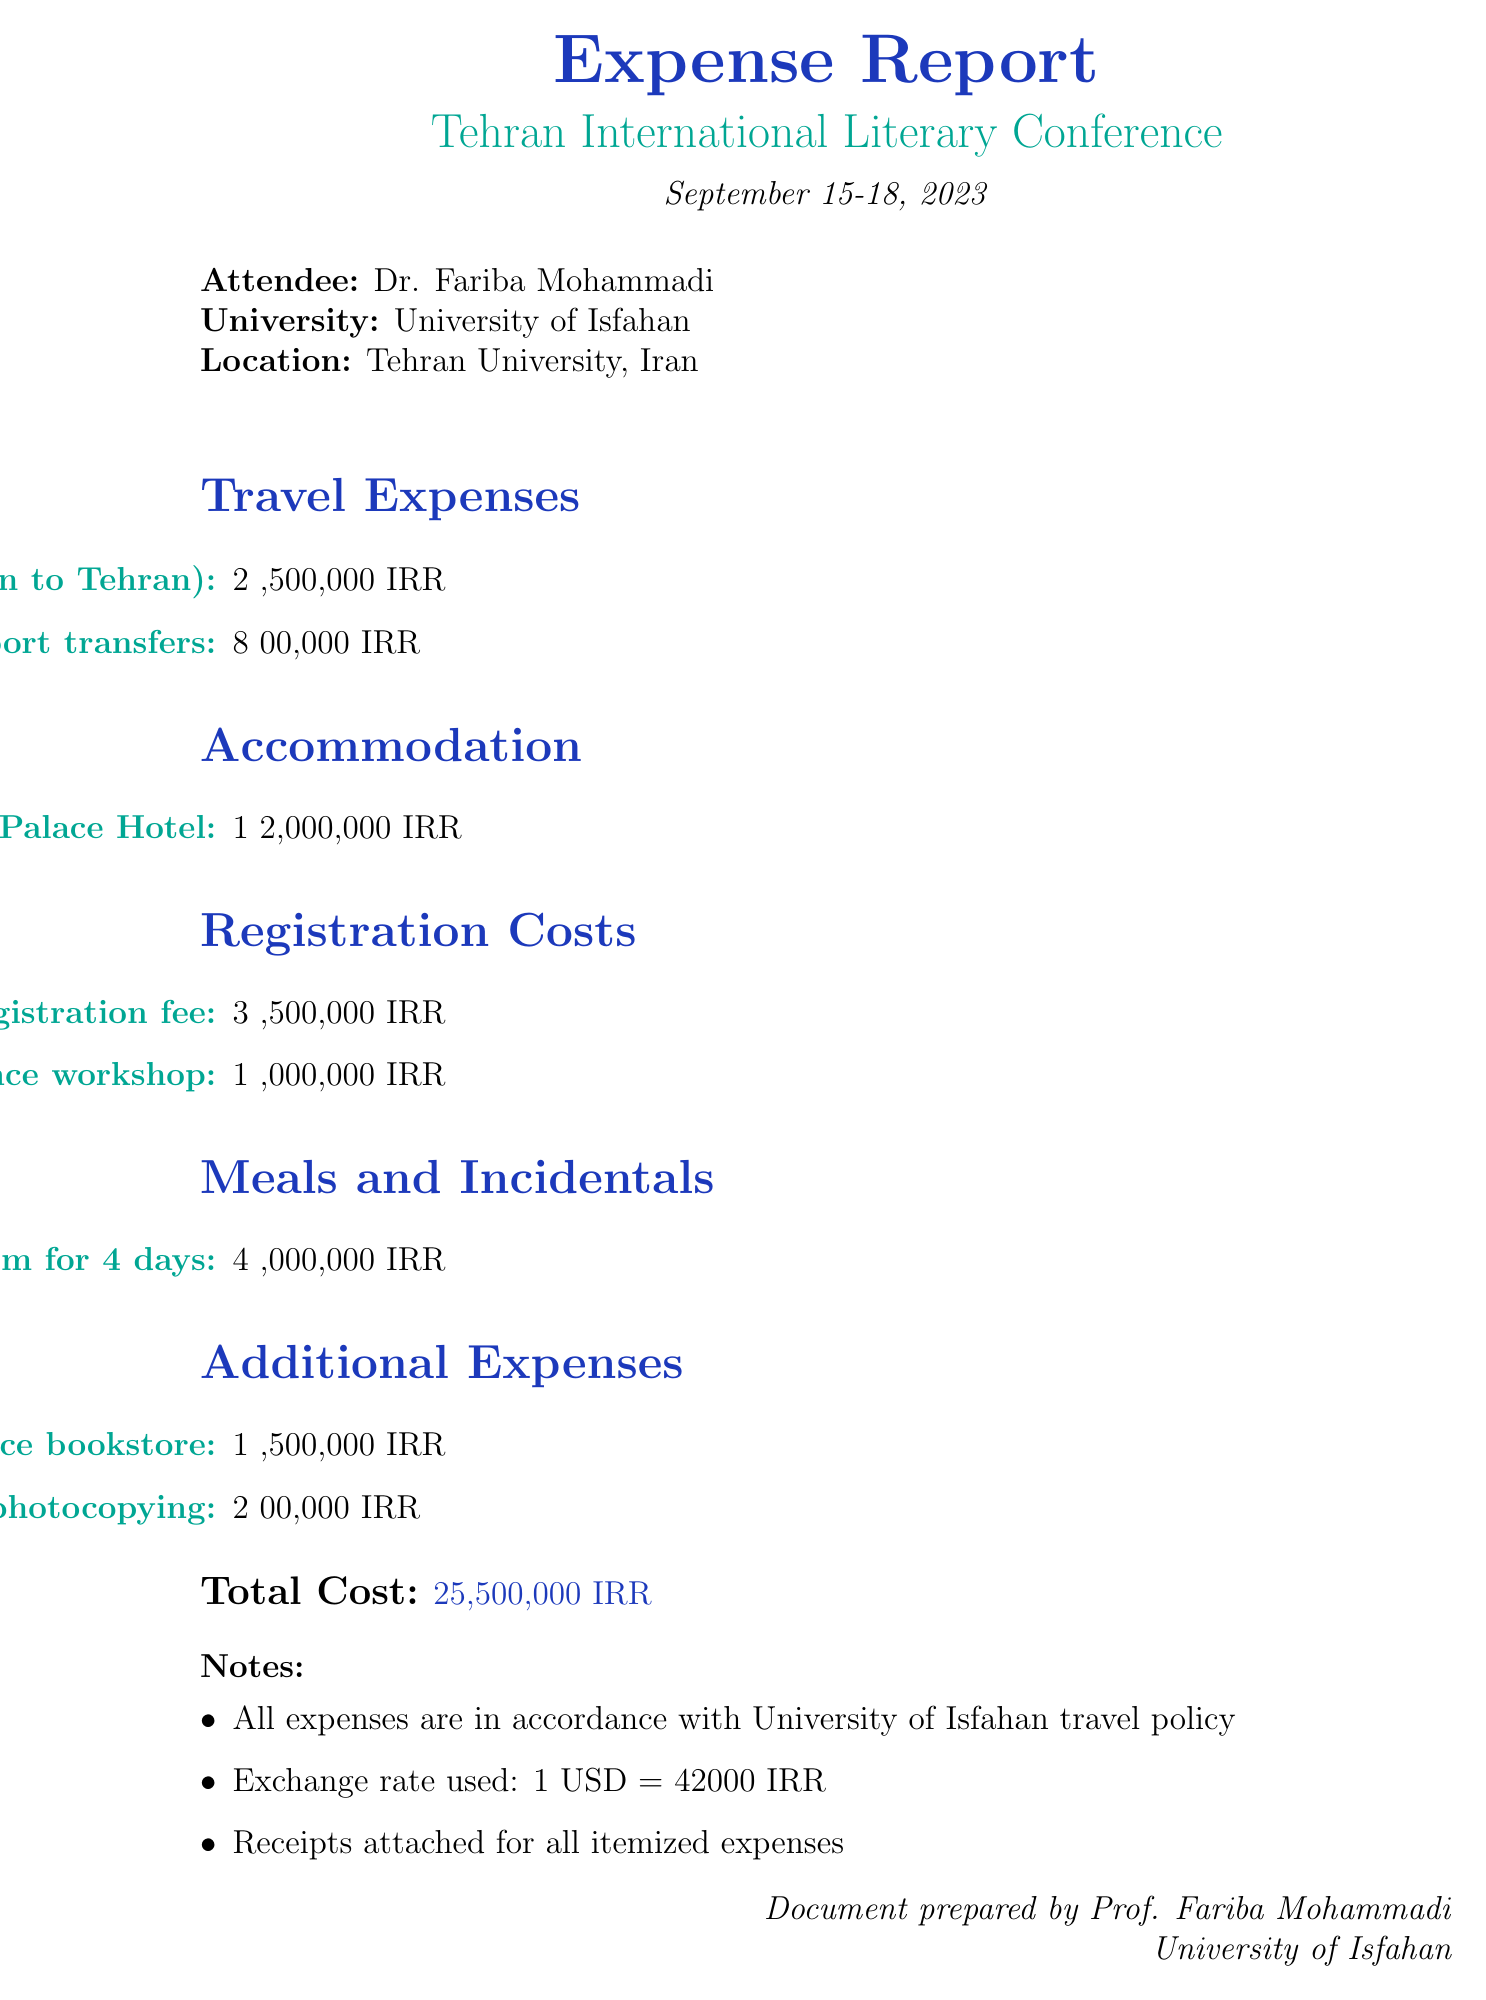What is the total cost of the expenses? The total cost is listed at the end of the document and sums all the expense categories.
Answer: 25,500,000 IRR Who attended the conference? The document specifies the attendee's name at the beginning.
Answer: Dr. Fariba Mohammadi What hotel was used for accommodation? The accommodation section provides the hotel name where the attendee stayed.
Answer: Espinas Palace Hotel What is the cost of the round-trip flight? The travel expenses section lists the cost of the round-trip flight to Tehran.
Answer: 2,500,000 IRR What was the conference registration fee? The registration costs section details the fee for attending the conference.
Answer: 3,500,000 IRR How many nights did the attendee stay at the hotel? The accommodation entry specifies the duration of the stay.
Answer: 4 nights Who presented the workshop on Modern Persian Poetry Analysis? The registration costs section provides the name associated with the workshop.
Answer: Dr. Simin Behbahani Memorial Foundation What is the daily rate for the per diem? The meals and incidentals section lists the daily rate for meals and incidentals.
Answer: 1,000,000 IRR Are receipts attached for the expenses? The notes section mentions the presence of receipts for all itemized expenses.
Answer: Yes 